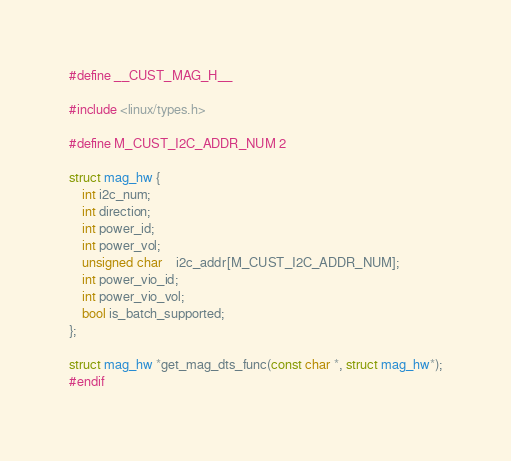<code> <loc_0><loc_0><loc_500><loc_500><_C_>#define __CUST_MAG_H__

#include <linux/types.h>

#define M_CUST_I2C_ADDR_NUM 2

struct mag_hw {
	int i2c_num;
	int direction;
	int power_id;
	int power_vol;
	unsigned char	i2c_addr[M_CUST_I2C_ADDR_NUM];
	int power_vio_id;
	int power_vio_vol;
	bool is_batch_supported;
};

struct mag_hw *get_mag_dts_func(const char *, struct mag_hw*);
#endif
</code> 